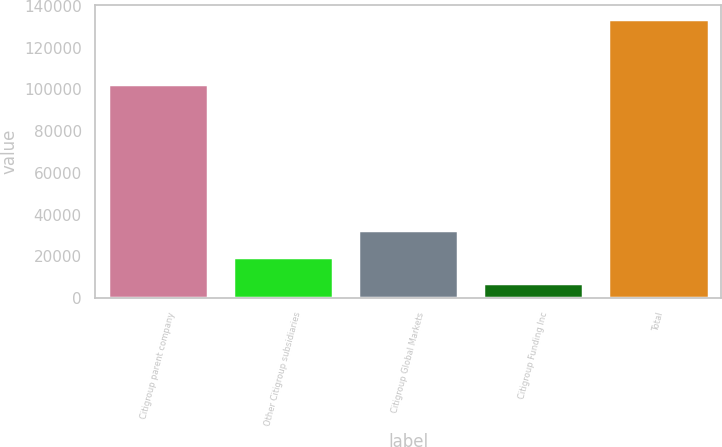<chart> <loc_0><loc_0><loc_500><loc_500><bar_chart><fcel>Citigroup parent company<fcel>Other Citigroup subsidiaries<fcel>Citigroup Global Markets<fcel>Citigroup Funding Inc<fcel>Total<nl><fcel>102794<fcel>19810<fcel>32456<fcel>7164<fcel>133624<nl></chart> 